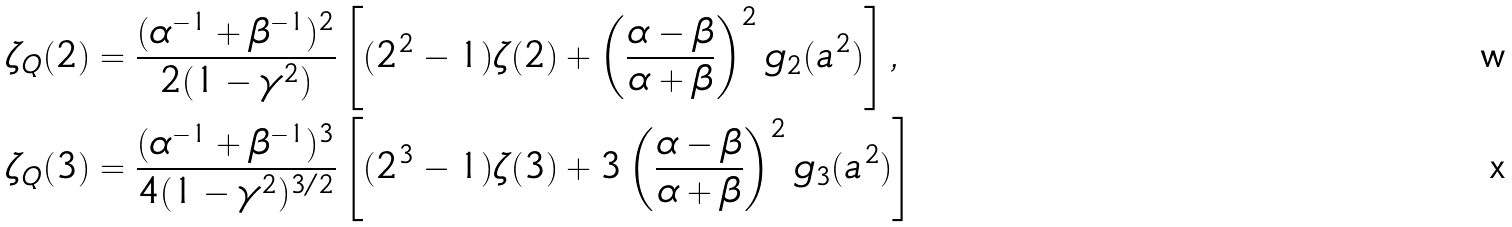<formula> <loc_0><loc_0><loc_500><loc_500>\zeta _ { Q } ( 2 ) & = \frac { ( \alpha ^ { - 1 } + \beta ^ { - 1 } ) ^ { 2 } } { 2 ( 1 - \gamma ^ { 2 } ) } \left [ ( 2 ^ { 2 } - 1 ) \zeta ( 2 ) + \left ( \frac { \alpha - \beta } { \alpha + \beta } \right ) ^ { 2 } g _ { 2 } ( a ^ { 2 } ) \right ] , \\ \zeta _ { Q } ( 3 ) & = \frac { ( \alpha ^ { - 1 } + \beta ^ { - 1 } ) ^ { 3 } } { 4 ( 1 - \gamma ^ { 2 } ) ^ { 3 / 2 } } \left [ ( 2 ^ { 3 } - 1 ) \zeta ( 3 ) + 3 \left ( \frac { \alpha - \beta } { \alpha + \beta } \right ) ^ { 2 } g _ { 3 } ( a ^ { 2 } ) \right ]</formula> 